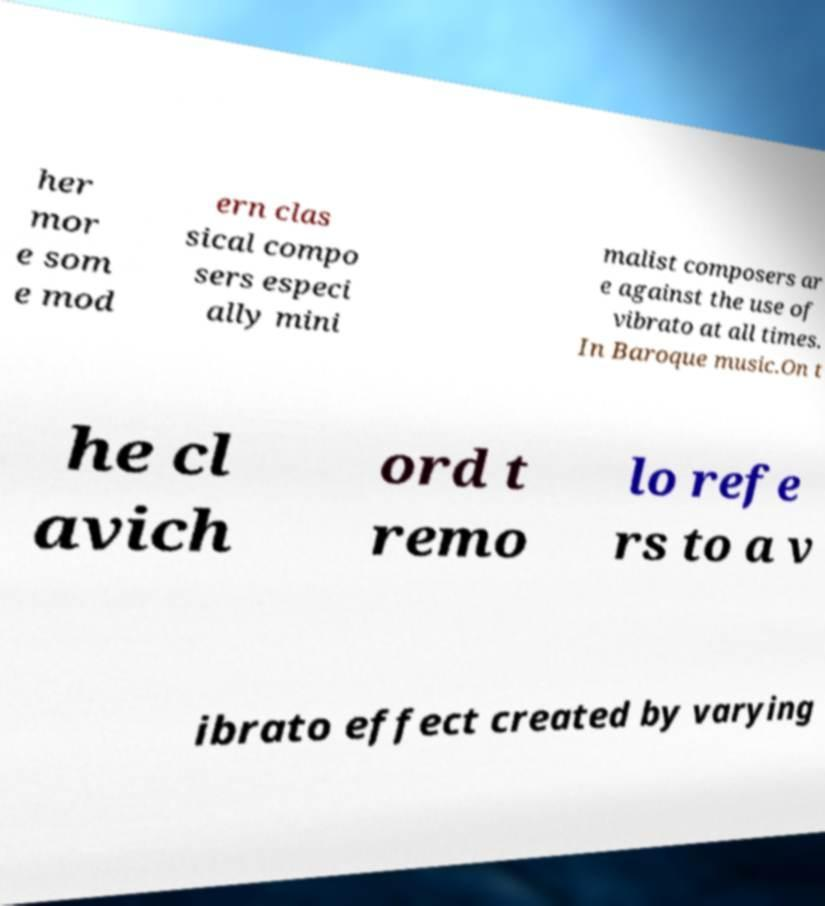There's text embedded in this image that I need extracted. Can you transcribe it verbatim? her mor e som e mod ern clas sical compo sers especi ally mini malist composers ar e against the use of vibrato at all times. In Baroque music.On t he cl avich ord t remo lo refe rs to a v ibrato effect created by varying 